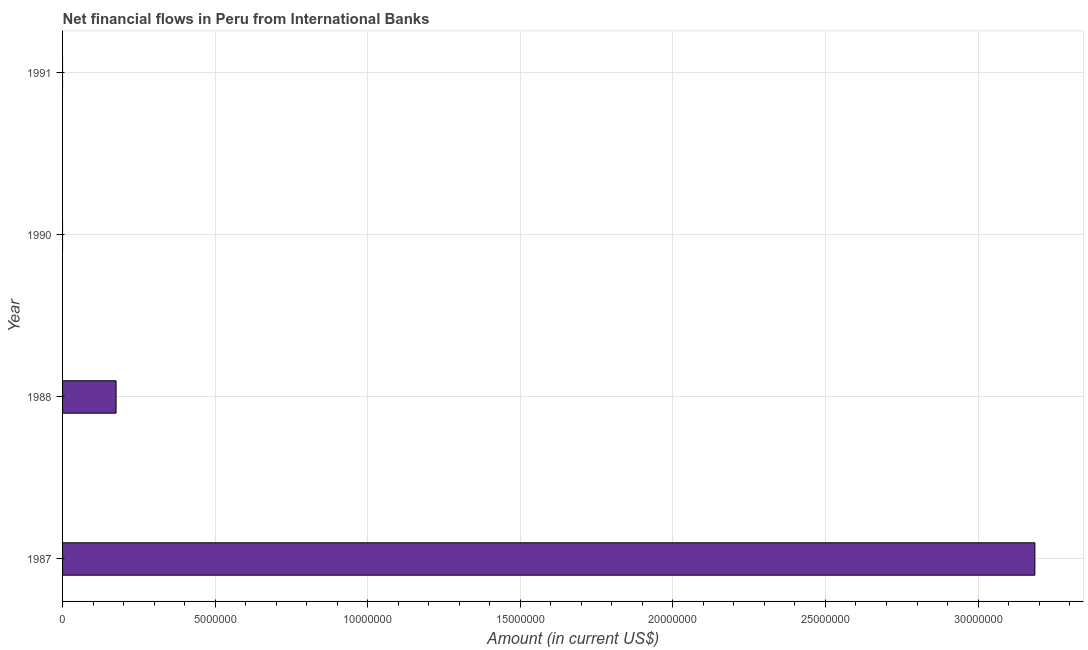Does the graph contain any zero values?
Provide a short and direct response. Yes. Does the graph contain grids?
Ensure brevity in your answer.  Yes. What is the title of the graph?
Your answer should be very brief. Net financial flows in Peru from International Banks. What is the net financial flows from ibrd in 1988?
Your answer should be compact. 1.75e+06. Across all years, what is the maximum net financial flows from ibrd?
Give a very brief answer. 3.19e+07. Across all years, what is the minimum net financial flows from ibrd?
Provide a succinct answer. 0. What is the sum of the net financial flows from ibrd?
Ensure brevity in your answer.  3.36e+07. What is the difference between the net financial flows from ibrd in 1987 and 1988?
Provide a succinct answer. 3.01e+07. What is the average net financial flows from ibrd per year?
Provide a short and direct response. 8.40e+06. What is the median net financial flows from ibrd?
Ensure brevity in your answer.  8.76e+05. In how many years, is the net financial flows from ibrd greater than 32000000 US$?
Keep it short and to the point. 0. Is the difference between the net financial flows from ibrd in 1987 and 1988 greater than the difference between any two years?
Your answer should be very brief. No. What is the difference between the highest and the lowest net financial flows from ibrd?
Your answer should be compact. 3.19e+07. In how many years, is the net financial flows from ibrd greater than the average net financial flows from ibrd taken over all years?
Ensure brevity in your answer.  1. Are all the bars in the graph horizontal?
Your answer should be very brief. Yes. How many years are there in the graph?
Offer a very short reply. 4. What is the Amount (in current US$) of 1987?
Offer a terse response. 3.19e+07. What is the Amount (in current US$) of 1988?
Give a very brief answer. 1.75e+06. What is the difference between the Amount (in current US$) in 1987 and 1988?
Ensure brevity in your answer.  3.01e+07. What is the ratio of the Amount (in current US$) in 1987 to that in 1988?
Keep it short and to the point. 18.18. 